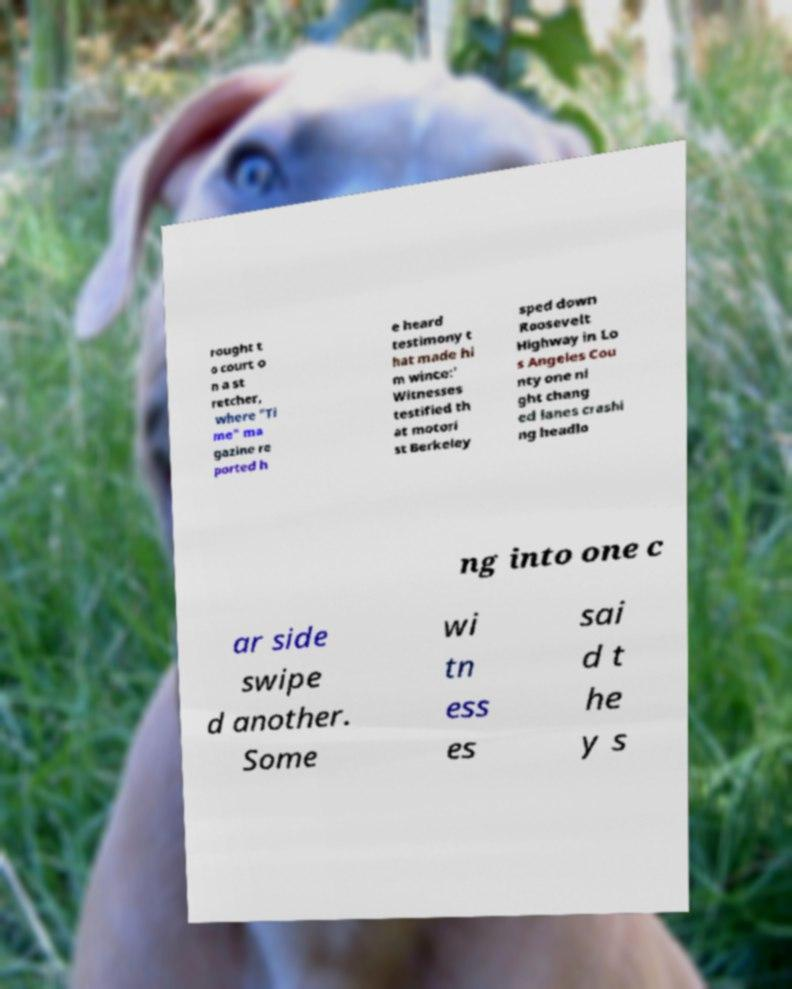Can you read and provide the text displayed in the image?This photo seems to have some interesting text. Can you extract and type it out for me? rought t o court o n a st retcher, where "Ti me" ma gazine re ported h e heard testimony t hat made hi m wince:' Witnesses testified th at motori st Berkeley sped down Roosevelt Highway in Lo s Angeles Cou nty one ni ght chang ed lanes crashi ng headlo ng into one c ar side swipe d another. Some wi tn ess es sai d t he y s 